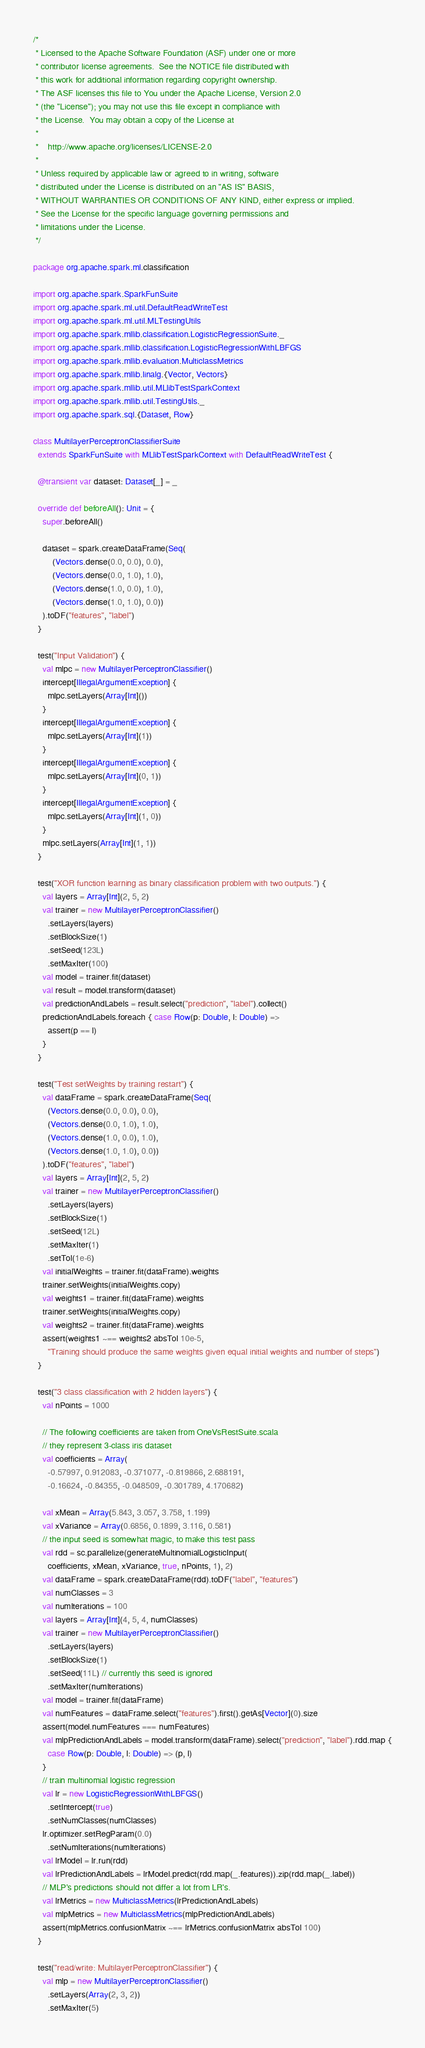<code> <loc_0><loc_0><loc_500><loc_500><_Scala_>/*
 * Licensed to the Apache Software Foundation (ASF) under one or more
 * contributor license agreements.  See the NOTICE file distributed with
 * this work for additional information regarding copyright ownership.
 * The ASF licenses this file to You under the Apache License, Version 2.0
 * (the "License"); you may not use this file except in compliance with
 * the License.  You may obtain a copy of the License at
 *
 *    http://www.apache.org/licenses/LICENSE-2.0
 *
 * Unless required by applicable law or agreed to in writing, software
 * distributed under the License is distributed on an "AS IS" BASIS,
 * WITHOUT WARRANTIES OR CONDITIONS OF ANY KIND, either express or implied.
 * See the License for the specific language governing permissions and
 * limitations under the License.
 */

package org.apache.spark.ml.classification

import org.apache.spark.SparkFunSuite
import org.apache.spark.ml.util.DefaultReadWriteTest
import org.apache.spark.ml.util.MLTestingUtils
import org.apache.spark.mllib.classification.LogisticRegressionSuite._
import org.apache.spark.mllib.classification.LogisticRegressionWithLBFGS
import org.apache.spark.mllib.evaluation.MulticlassMetrics
import org.apache.spark.mllib.linalg.{Vector, Vectors}
import org.apache.spark.mllib.util.MLlibTestSparkContext
import org.apache.spark.mllib.util.TestingUtils._
import org.apache.spark.sql.{Dataset, Row}

class MultilayerPerceptronClassifierSuite
  extends SparkFunSuite with MLlibTestSparkContext with DefaultReadWriteTest {

  @transient var dataset: Dataset[_] = _

  override def beforeAll(): Unit = {
    super.beforeAll()

    dataset = spark.createDataFrame(Seq(
        (Vectors.dense(0.0, 0.0), 0.0),
        (Vectors.dense(0.0, 1.0), 1.0),
        (Vectors.dense(1.0, 0.0), 1.0),
        (Vectors.dense(1.0, 1.0), 0.0))
    ).toDF("features", "label")
  }

  test("Input Validation") {
    val mlpc = new MultilayerPerceptronClassifier()
    intercept[IllegalArgumentException] {
      mlpc.setLayers(Array[Int]())
    }
    intercept[IllegalArgumentException] {
      mlpc.setLayers(Array[Int](1))
    }
    intercept[IllegalArgumentException] {
      mlpc.setLayers(Array[Int](0, 1))
    }
    intercept[IllegalArgumentException] {
      mlpc.setLayers(Array[Int](1, 0))
    }
    mlpc.setLayers(Array[Int](1, 1))
  }

  test("XOR function learning as binary classification problem with two outputs.") {
    val layers = Array[Int](2, 5, 2)
    val trainer = new MultilayerPerceptronClassifier()
      .setLayers(layers)
      .setBlockSize(1)
      .setSeed(123L)
      .setMaxIter(100)
    val model = trainer.fit(dataset)
    val result = model.transform(dataset)
    val predictionAndLabels = result.select("prediction", "label").collect()
    predictionAndLabels.foreach { case Row(p: Double, l: Double) =>
      assert(p == l)
    }
  }

  test("Test setWeights by training restart") {
    val dataFrame = spark.createDataFrame(Seq(
      (Vectors.dense(0.0, 0.0), 0.0),
      (Vectors.dense(0.0, 1.0), 1.0),
      (Vectors.dense(1.0, 0.0), 1.0),
      (Vectors.dense(1.0, 1.0), 0.0))
    ).toDF("features", "label")
    val layers = Array[Int](2, 5, 2)
    val trainer = new MultilayerPerceptronClassifier()
      .setLayers(layers)
      .setBlockSize(1)
      .setSeed(12L)
      .setMaxIter(1)
      .setTol(1e-6)
    val initialWeights = trainer.fit(dataFrame).weights
    trainer.setWeights(initialWeights.copy)
    val weights1 = trainer.fit(dataFrame).weights
    trainer.setWeights(initialWeights.copy)
    val weights2 = trainer.fit(dataFrame).weights
    assert(weights1 ~== weights2 absTol 10e-5,
      "Training should produce the same weights given equal initial weights and number of steps")
  }

  test("3 class classification with 2 hidden layers") {
    val nPoints = 1000

    // The following coefficients are taken from OneVsRestSuite.scala
    // they represent 3-class iris dataset
    val coefficients = Array(
      -0.57997, 0.912083, -0.371077, -0.819866, 2.688191,
      -0.16624, -0.84355, -0.048509, -0.301789, 4.170682)

    val xMean = Array(5.843, 3.057, 3.758, 1.199)
    val xVariance = Array(0.6856, 0.1899, 3.116, 0.581)
    // the input seed is somewhat magic, to make this test pass
    val rdd = sc.parallelize(generateMultinomialLogisticInput(
      coefficients, xMean, xVariance, true, nPoints, 1), 2)
    val dataFrame = spark.createDataFrame(rdd).toDF("label", "features")
    val numClasses = 3
    val numIterations = 100
    val layers = Array[Int](4, 5, 4, numClasses)
    val trainer = new MultilayerPerceptronClassifier()
      .setLayers(layers)
      .setBlockSize(1)
      .setSeed(11L) // currently this seed is ignored
      .setMaxIter(numIterations)
    val model = trainer.fit(dataFrame)
    val numFeatures = dataFrame.select("features").first().getAs[Vector](0).size
    assert(model.numFeatures === numFeatures)
    val mlpPredictionAndLabels = model.transform(dataFrame).select("prediction", "label").rdd.map {
      case Row(p: Double, l: Double) => (p, l)
    }
    // train multinomial logistic regression
    val lr = new LogisticRegressionWithLBFGS()
      .setIntercept(true)
      .setNumClasses(numClasses)
    lr.optimizer.setRegParam(0.0)
      .setNumIterations(numIterations)
    val lrModel = lr.run(rdd)
    val lrPredictionAndLabels = lrModel.predict(rdd.map(_.features)).zip(rdd.map(_.label))
    // MLP's predictions should not differ a lot from LR's.
    val lrMetrics = new MulticlassMetrics(lrPredictionAndLabels)
    val mlpMetrics = new MulticlassMetrics(mlpPredictionAndLabels)
    assert(mlpMetrics.confusionMatrix ~== lrMetrics.confusionMatrix absTol 100)
  }

  test("read/write: MultilayerPerceptronClassifier") {
    val mlp = new MultilayerPerceptronClassifier()
      .setLayers(Array(2, 3, 2))
      .setMaxIter(5)</code> 